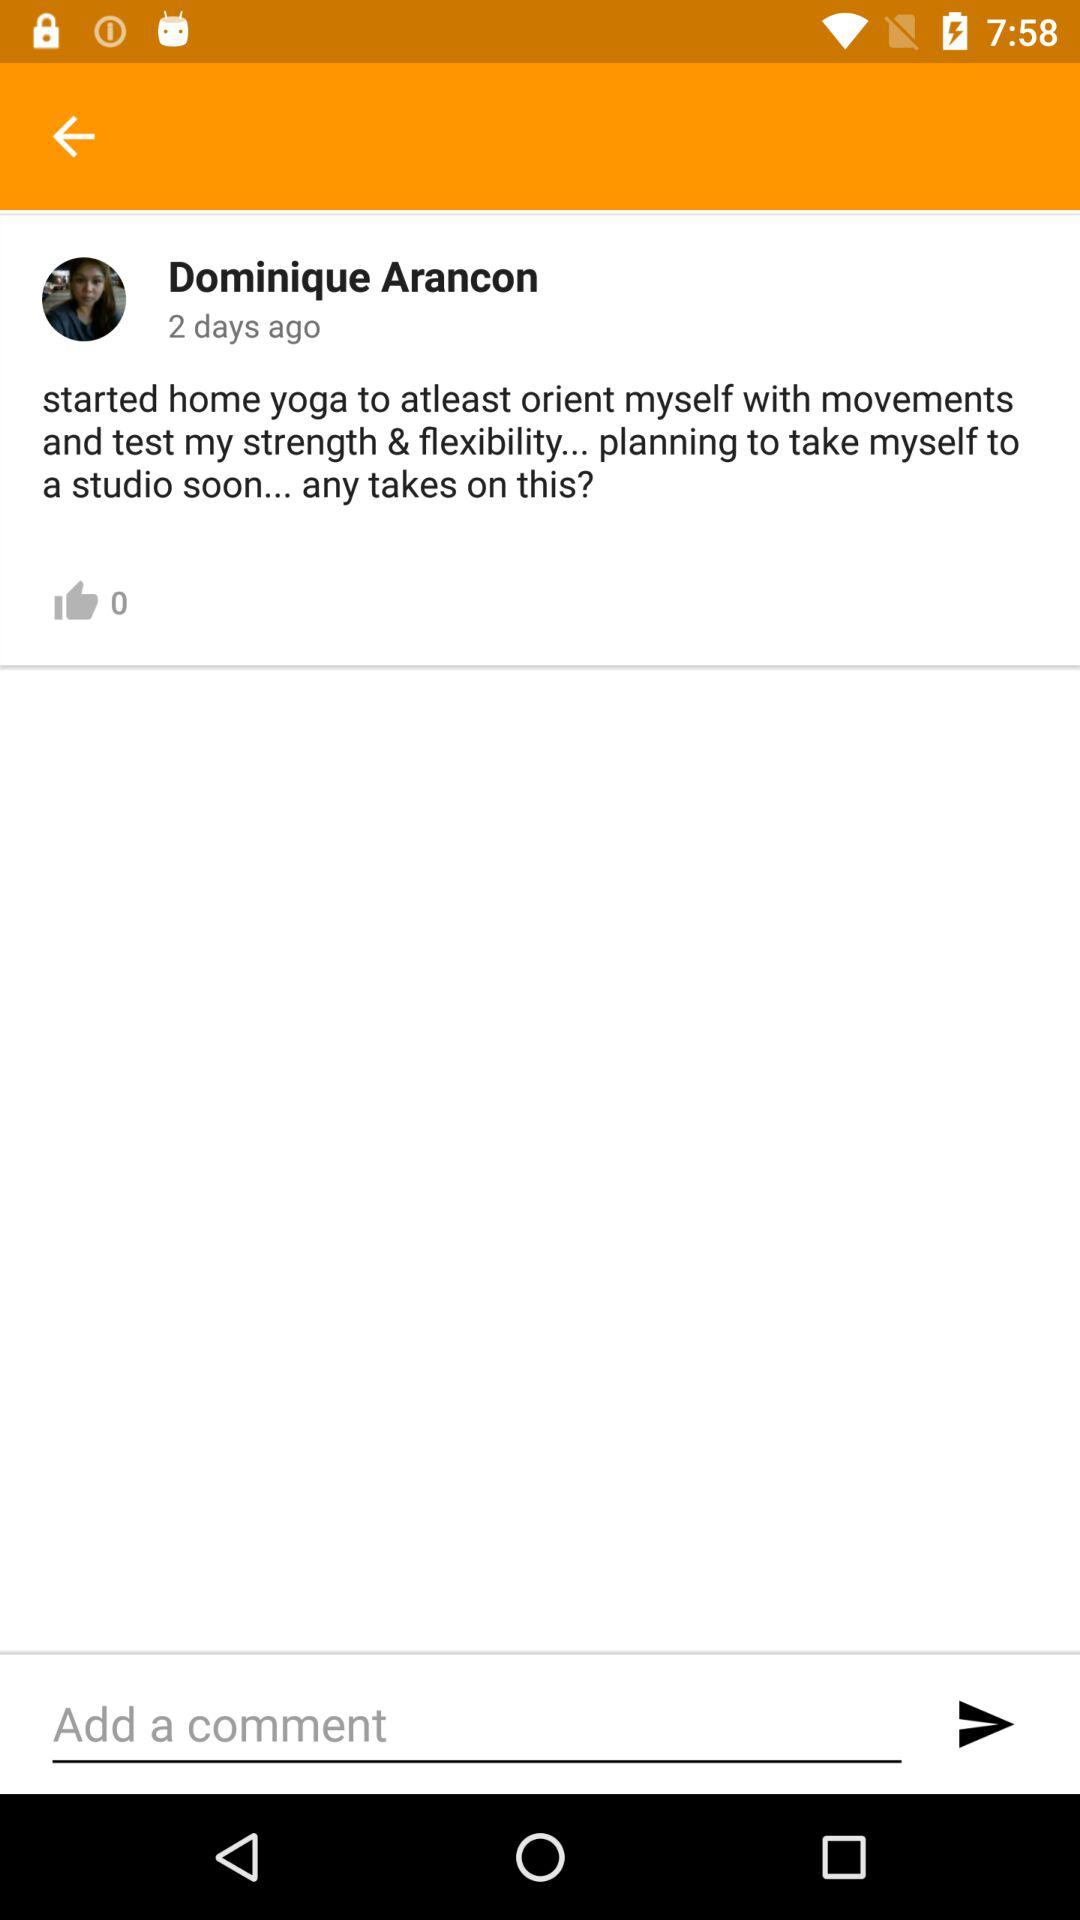What is the profile name? The profile name is Dominique Arancon. 